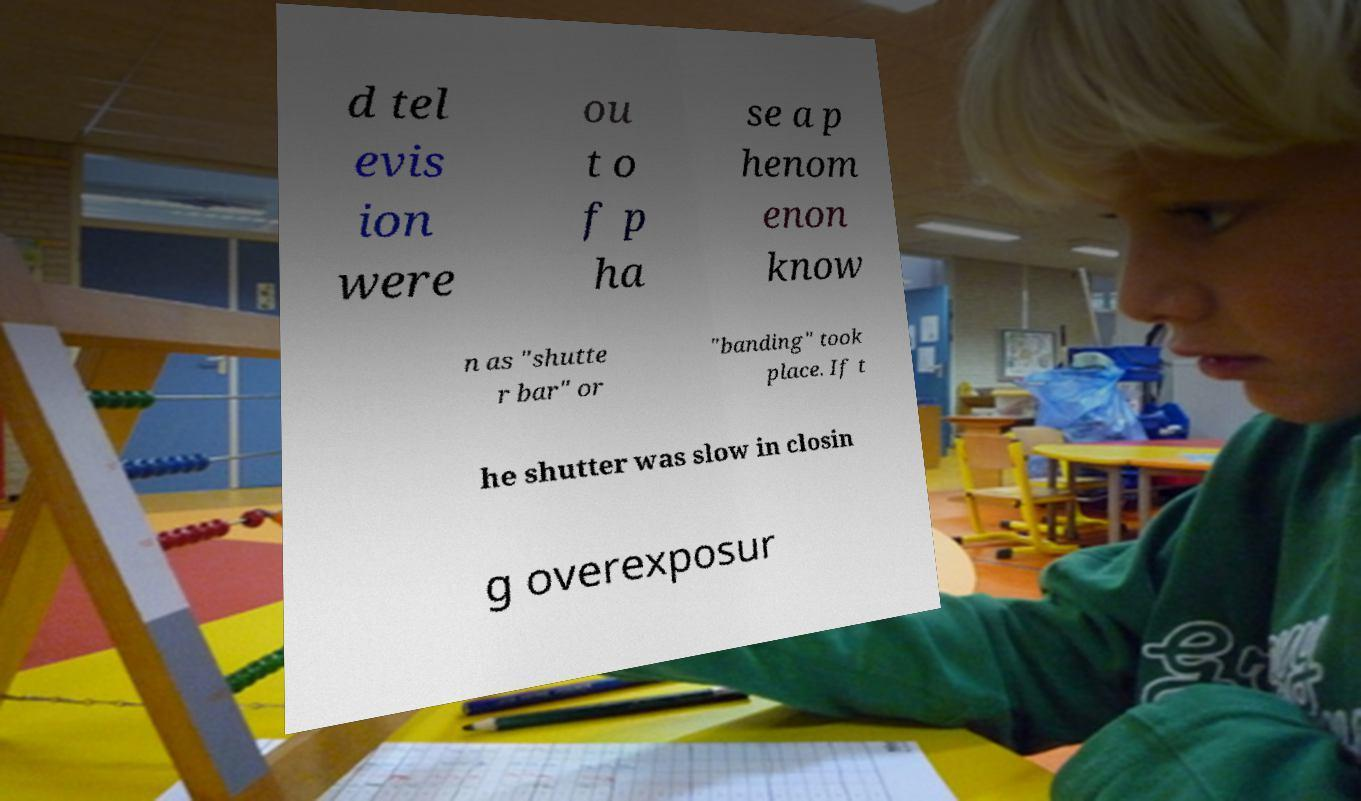Can you read and provide the text displayed in the image?This photo seems to have some interesting text. Can you extract and type it out for me? d tel evis ion were ou t o f p ha se a p henom enon know n as "shutte r bar" or "banding" took place. If t he shutter was slow in closin g overexposur 